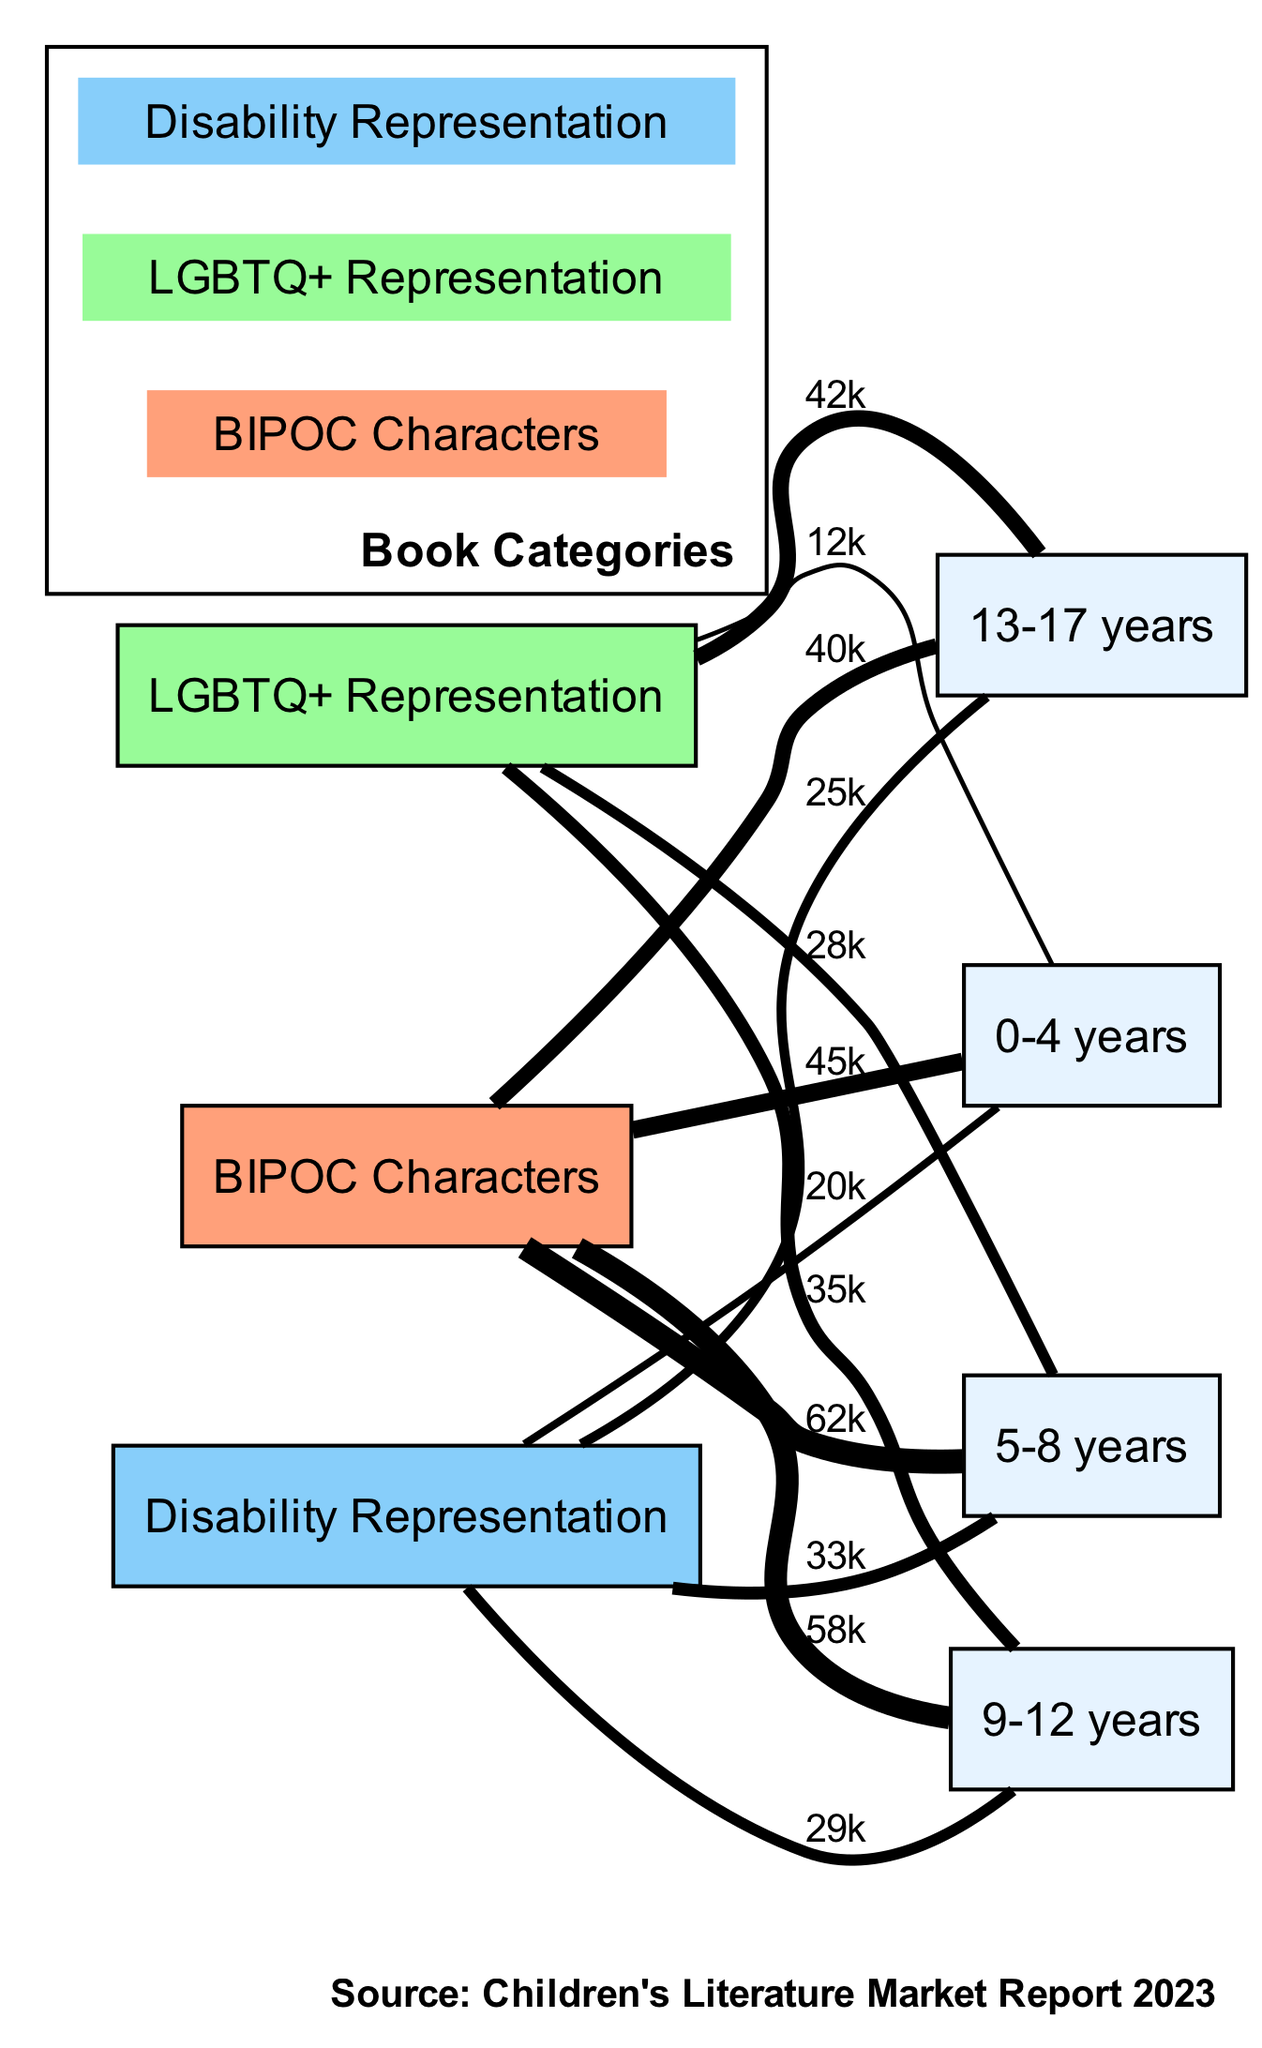What is the highest sales figure for BIPOC Characters? The sales figures for BIPOC Characters are 45, 62, 58, and 40 across the age groups. The highest value among these is 62.
Answer: 62 Which age group has the lowest sales for Disability Representation? The sales figures for Disability Representation are 20, 33, 29, and 25 across the age groups. The lowest value among these is 20, corresponding to the 0-4 years age group.
Answer: 20 How many different book categories are represented in the diagram? There are three distinct book categories shown in the diagram: BIPOC Characters, LGBTQ+ Representation, and Disability Representation.
Answer: 3 What are the sales figures for LGBTQ+ Representation in the 5-8 years age group? The sales figures for LGBTQ+ Representation are provided as follows: 12, 28, 35, and 42 for the respective age groups. For the 5-8 years age group, the value is 28.
Answer: 28 Which category has the highest sales figure in the 9-12 years age group? Looking at the sales figures for each category in the 9-12 years age group: BIPOC Characters (58), LGBTQ+ Representation (35), and Disability Representation (29). BIPOC Characters has the highest figure of 58.
Answer: BIPOC Characters What is the total sales figure for all categories combined in the 0-4 years age group? The sales figures for the 0-4 years age group are: BIPOC Characters (45), LGBTQ+ Representation (12), and Disability Representation (20). To find the total, we sum these: 45 + 12 + 20 = 77.
Answer: 77 Which category shows a consistent increase in sales across all age groups? When analyzing the sales figures, BIPOC Characters (45, 62, 58, 40) and Disability Representation (20, 33, 29, 25) do not show consistent increases. However, LGBTQ+ Representation shows an increase from 12 to 42.
Answer: LGBTQ+ Representation How many sales are shown for the 13-17 years age group for Disability Representation? The sales figure for Disability Representation in the 13-17 years age group is clearly stated as 25.
Answer: 25 